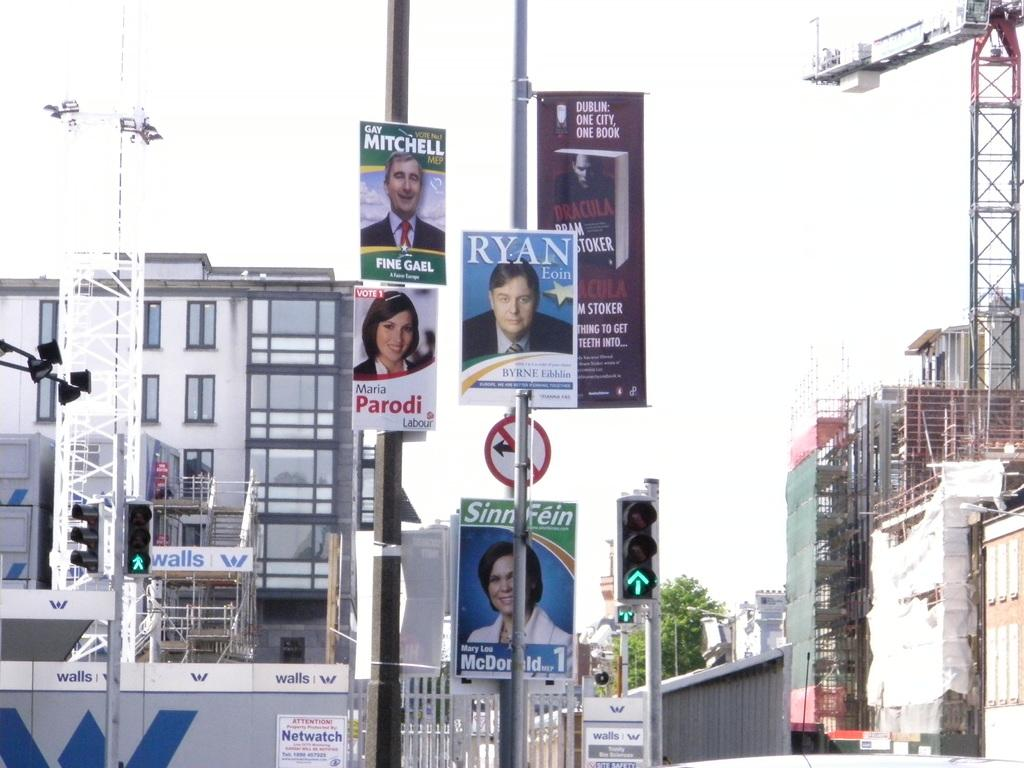<image>
Render a clear and concise summary of the photo. Posters of Ryan Eoin, Gay Mitchell, and Sinnfein. 